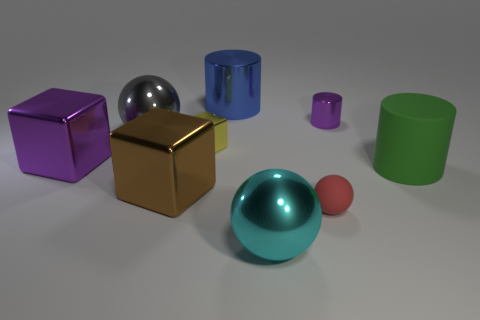Subtract all large blocks. How many blocks are left? 1 Subtract all tiny spheres. Subtract all large brown metal things. How many objects are left? 7 Add 9 big brown metallic objects. How many big brown metallic objects are left? 10 Add 7 shiny cylinders. How many shiny cylinders exist? 9 Subtract 0 blue cubes. How many objects are left? 9 Subtract all balls. How many objects are left? 6 Subtract 3 balls. How many balls are left? 0 Subtract all brown cubes. Subtract all gray cylinders. How many cubes are left? 2 Subtract all red cylinders. How many purple cubes are left? 1 